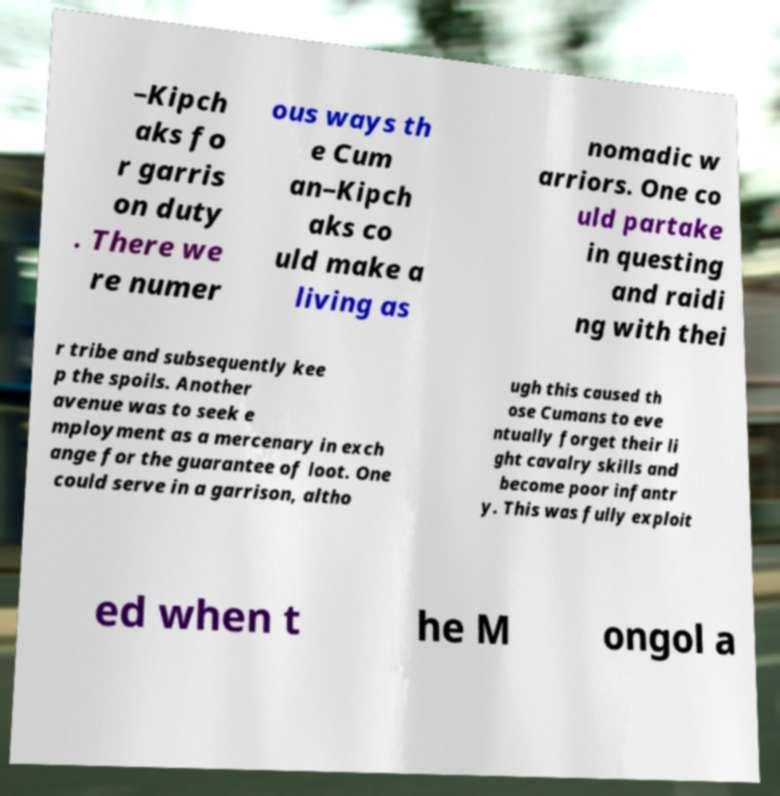Could you assist in decoding the text presented in this image and type it out clearly? –Kipch aks fo r garris on duty . There we re numer ous ways th e Cum an–Kipch aks co uld make a living as nomadic w arriors. One co uld partake in questing and raidi ng with thei r tribe and subsequently kee p the spoils. Another avenue was to seek e mployment as a mercenary in exch ange for the guarantee of loot. One could serve in a garrison, altho ugh this caused th ose Cumans to eve ntually forget their li ght cavalry skills and become poor infantr y. This was fully exploit ed when t he M ongol a 